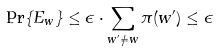Convert formula to latex. <formula><loc_0><loc_0><loc_500><loc_500>\Pr \{ E _ { w } \} \leq \epsilon \cdot \sum _ { w ^ { \prime } \neq w } \pi ( w ^ { \prime } ) \leq \epsilon</formula> 